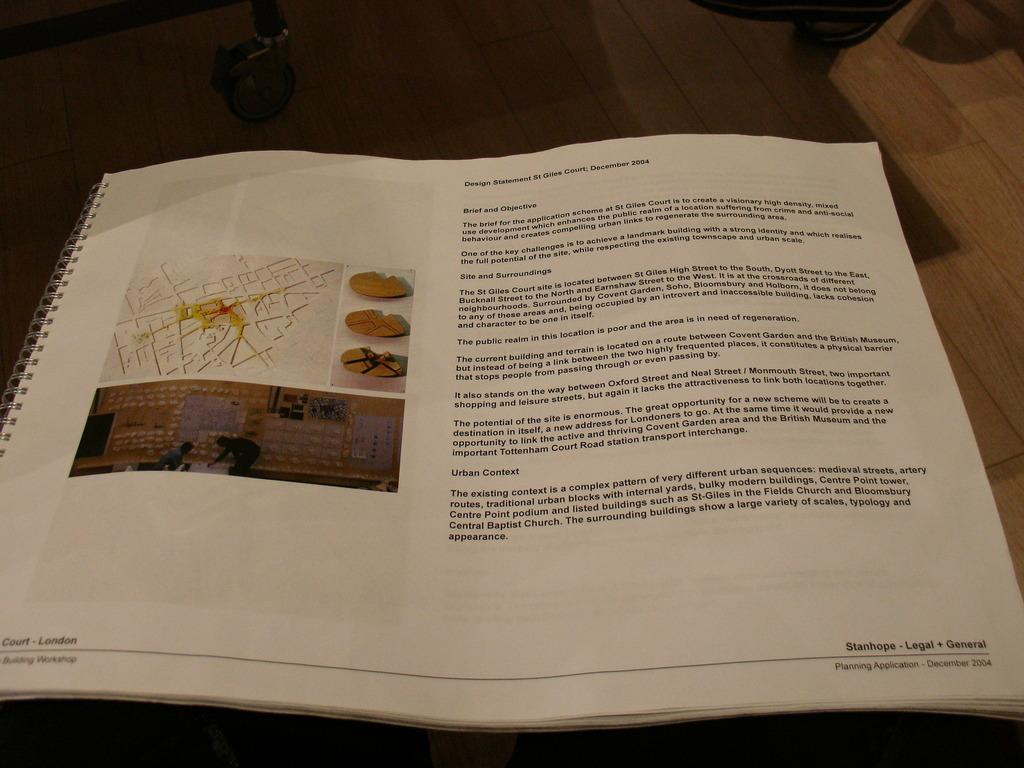What is the main object in the image? There is a book in the image. What can be seen on the right side of the book? The book has text on the right side. What is on the left side of the book? The book has a picture on the left side. Can you describe the object near the book? Unfortunately, the provided facts do not give any information about the object near the book. How does the bean cry in the image? There is no bean or any indication of crying in the image. 